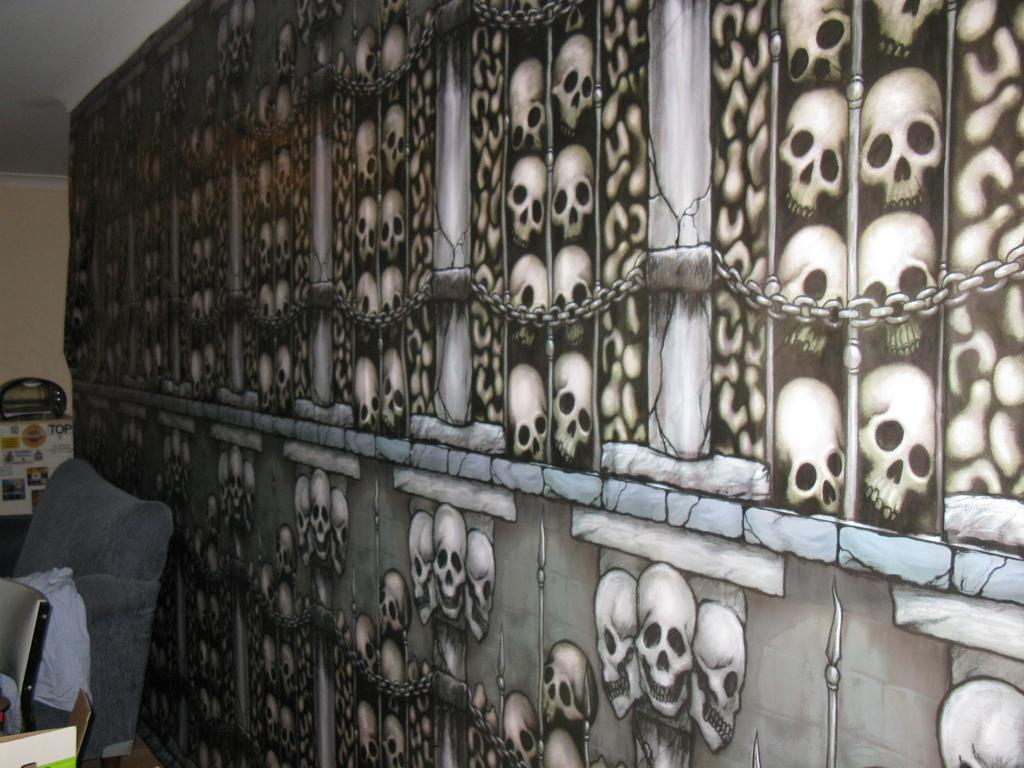What is present on the wall in the image? There are skull pictures on the wall. What can be found on the left side of the image? There are cardboard cartons and a chair on the left side of the image. What type of beam is holding up the ceiling in the image? There is no mention of a ceiling or any beams in the image; it only features a wall with skull pictures, cardboard cartons, and a chair. Can you tell me if the judge in the image has given their approval? There is no judge or any indication of approval or disapproval in the image. 